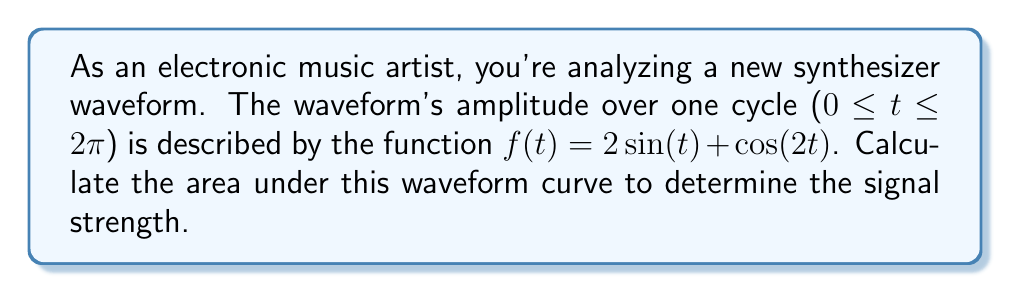Provide a solution to this math problem. To find the area under the waveform curve, we need to integrate the function over one complete cycle:

1) Set up the definite integral:
   $$\int_0^{2\pi} (2\sin(t) + \cos(2t)) dt$$

2) Integrate each term separately:
   For $2\sin(t)$: $\int 2\sin(t) dt = -2\cos(t) + C$
   For $\cos(2t)$: $\int \cos(2t) dt = \frac{1}{2}\sin(2t) + C$

3) Apply the fundamental theorem of calculus:
   $$\left[-2\cos(t) + \frac{1}{2}\sin(2t)\right]_0^{2\pi}$$

4) Evaluate at the bounds:
   At $t = 2\pi$: $-2\cos(2\pi) + \frac{1}{2}\sin(4\pi) = -2 + 0 = -2$
   At $t = 0$: $-2\cos(0) + \frac{1}{2}\sin(0) = -2 + 0 = -2$

5) Subtract the lower bound from the upper bound:
   $(-2) - (-2) = 0$

The area under the curve over one complete cycle is 0, indicating that the positive and negative parts of the waveform cancel out exactly.
Answer: 0 